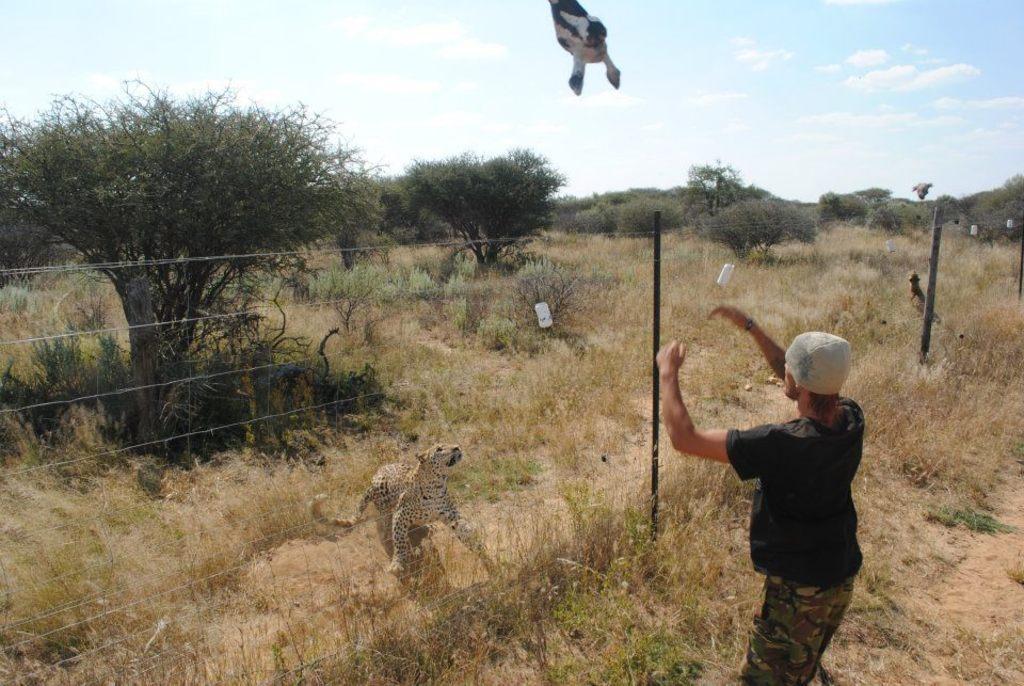Can you describe this image briefly? In the image there is a man with grey cap,black t-shirt and camouflage pant standing outside fence on grass land, in front there is cheetah looking at the food in air, the land is totally covered with dry grass and plants all over it and above its sky with clouds. 